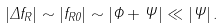<formula> <loc_0><loc_0><loc_500><loc_500>| \Delta f _ { R } | \sim | f _ { R 0 } | \sim | \Phi + \Psi | \ll | \Psi | \, .</formula> 